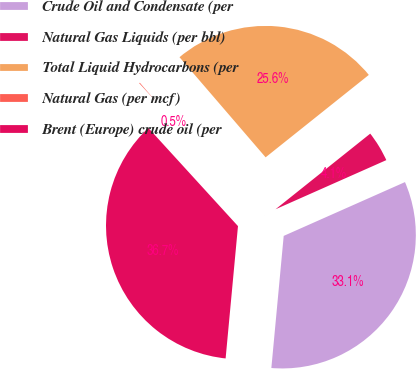Convert chart to OTSL. <chart><loc_0><loc_0><loc_500><loc_500><pie_chart><fcel>Crude Oil and Condensate (per<fcel>Natural Gas Liquids (per bbl)<fcel>Total Liquid Hydrocarbons (per<fcel>Natural Gas (per mcf)<fcel>Brent (Europe) crude oil (per<nl><fcel>33.13%<fcel>4.08%<fcel>25.58%<fcel>0.47%<fcel>36.74%<nl></chart> 